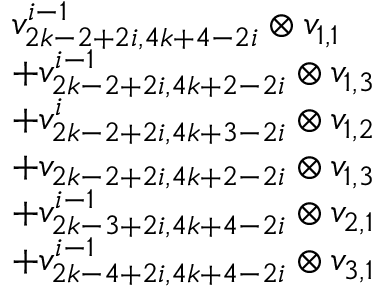Convert formula to latex. <formula><loc_0><loc_0><loc_500><loc_500>\begin{array} { r l } & { v _ { 2 k - 2 + 2 i , 4 k + 4 - 2 i } ^ { i - 1 } \otimes v _ { 1 , 1 } } \\ & { + v _ { 2 k - 2 + 2 i , 4 k + 2 - 2 i } ^ { i - 1 } \otimes v _ { 1 , 3 } } \\ & { + v _ { 2 k - 2 + 2 i , 4 k + 3 - 2 i } ^ { i } \otimes v _ { 1 , 2 } } \\ & { + v _ { 2 k - 2 + 2 i , 4 k + 2 - 2 i } \otimes v _ { 1 , 3 } } \\ & { + v _ { 2 k - 3 + 2 i , 4 k + 4 - 2 i } ^ { i - 1 } \otimes v _ { 2 , 1 } } \\ & { + v _ { 2 k - 4 + 2 i , 4 k + 4 - 2 i } ^ { i - 1 } \otimes v _ { 3 , 1 } } \end{array}</formula> 